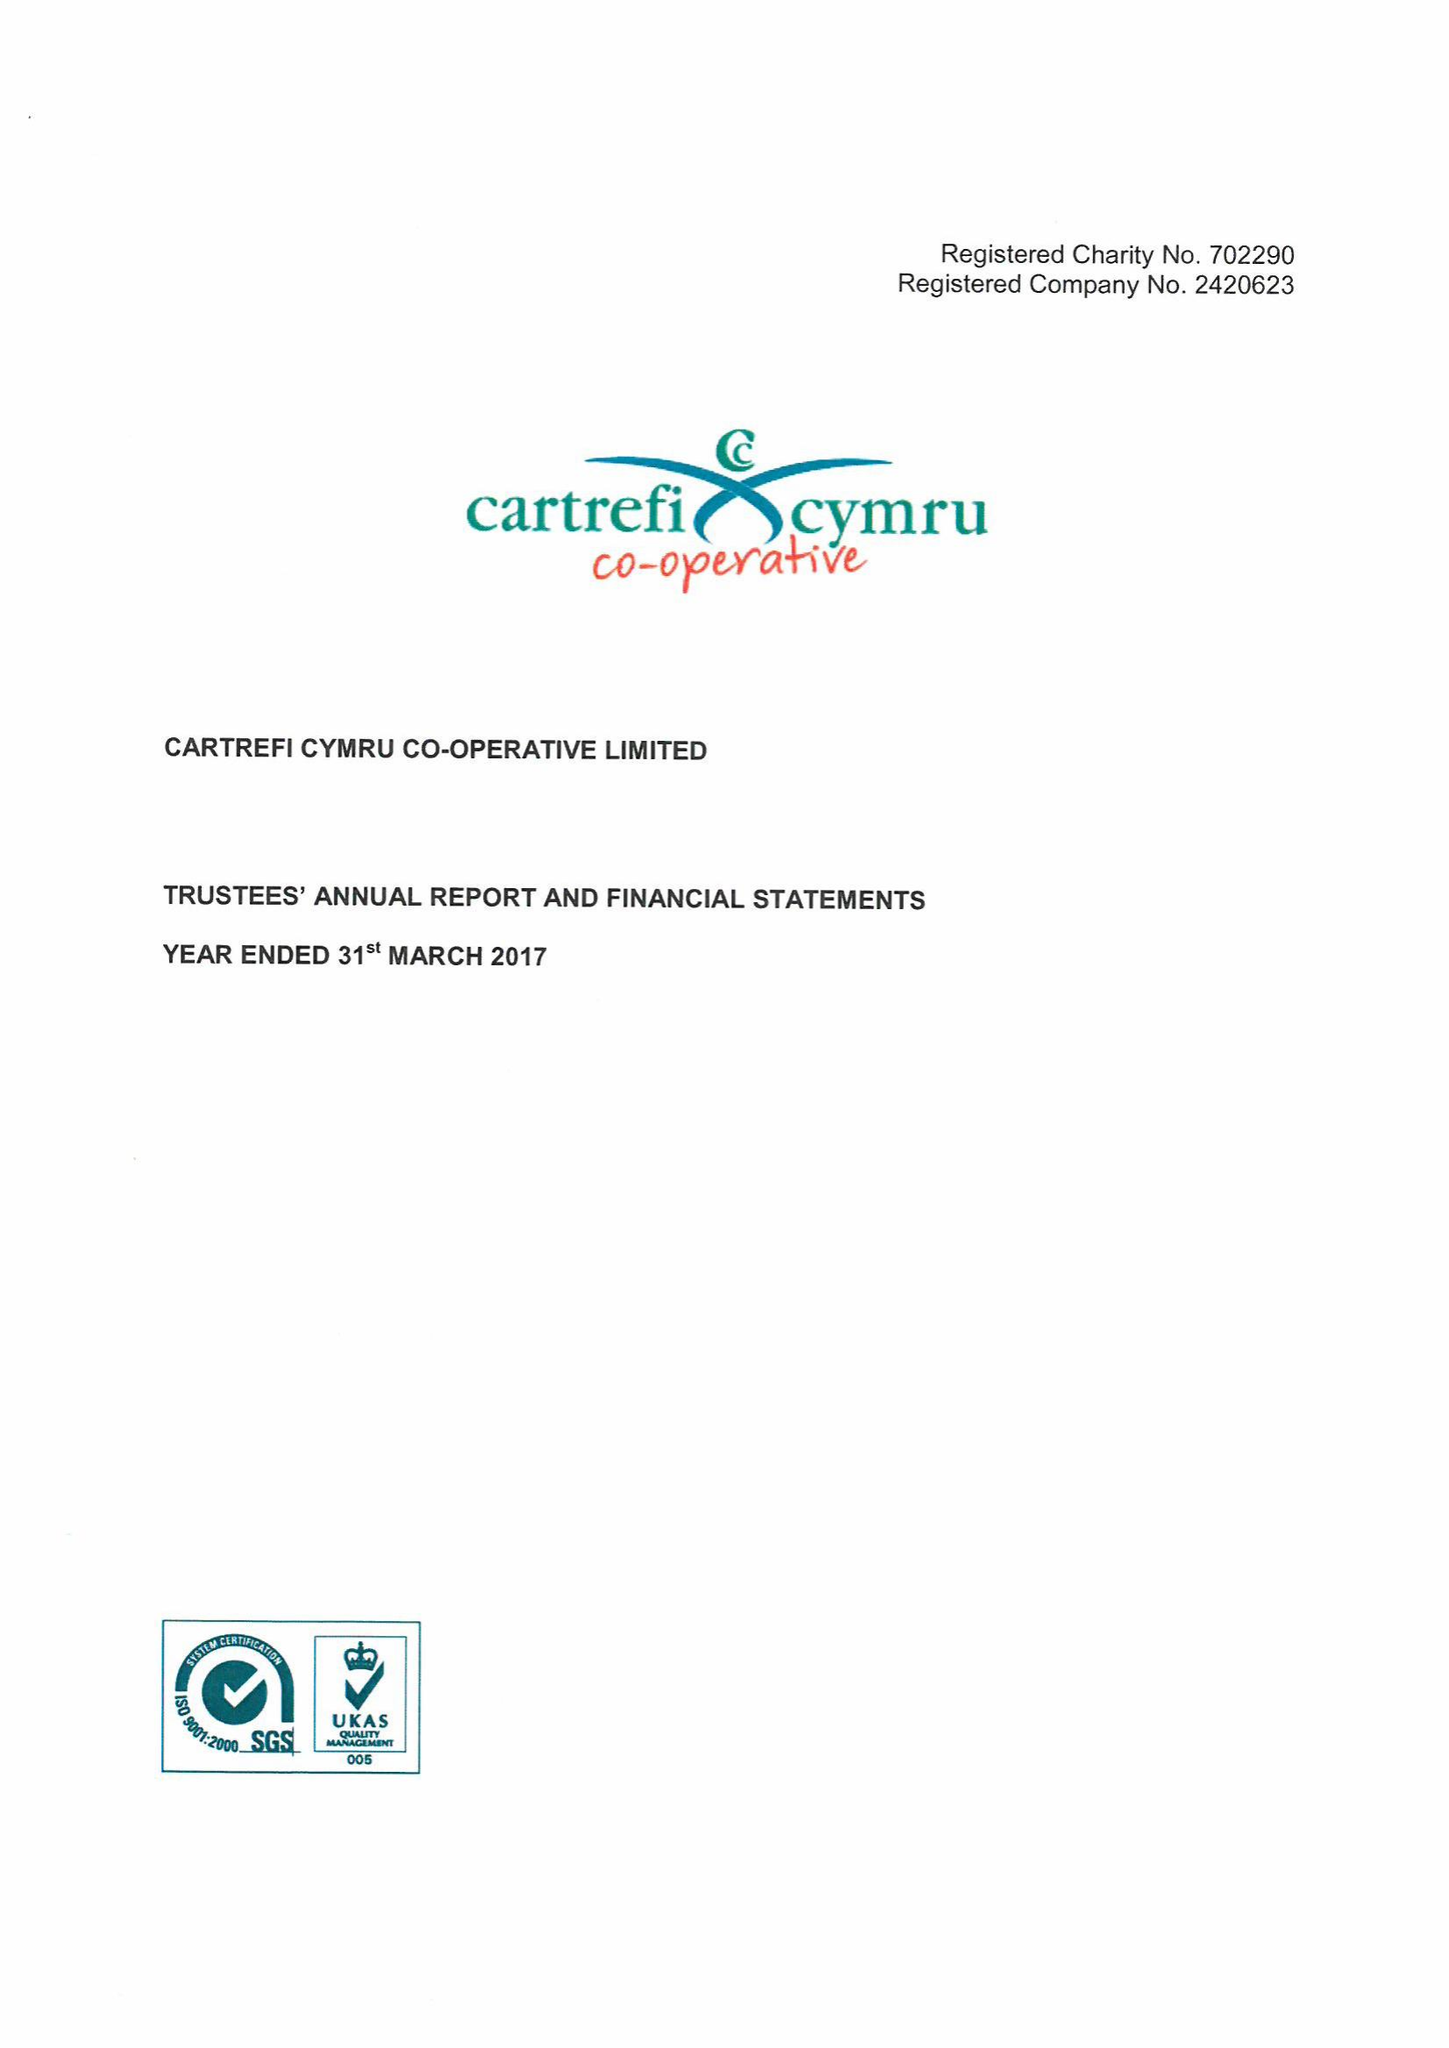What is the value for the income_annually_in_british_pounds?
Answer the question using a single word or phrase. 22690000.00 